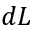<formula> <loc_0><loc_0><loc_500><loc_500>d L</formula> 